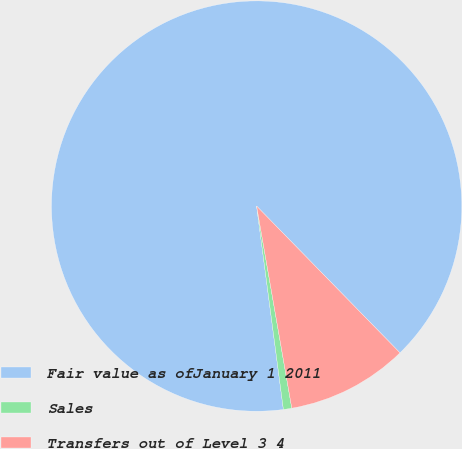Convert chart to OTSL. <chart><loc_0><loc_0><loc_500><loc_500><pie_chart><fcel>Fair value as ofJanuary 1 2011<fcel>Sales<fcel>Transfers out of Level 3 4<nl><fcel>89.77%<fcel>0.66%<fcel>9.57%<nl></chart> 